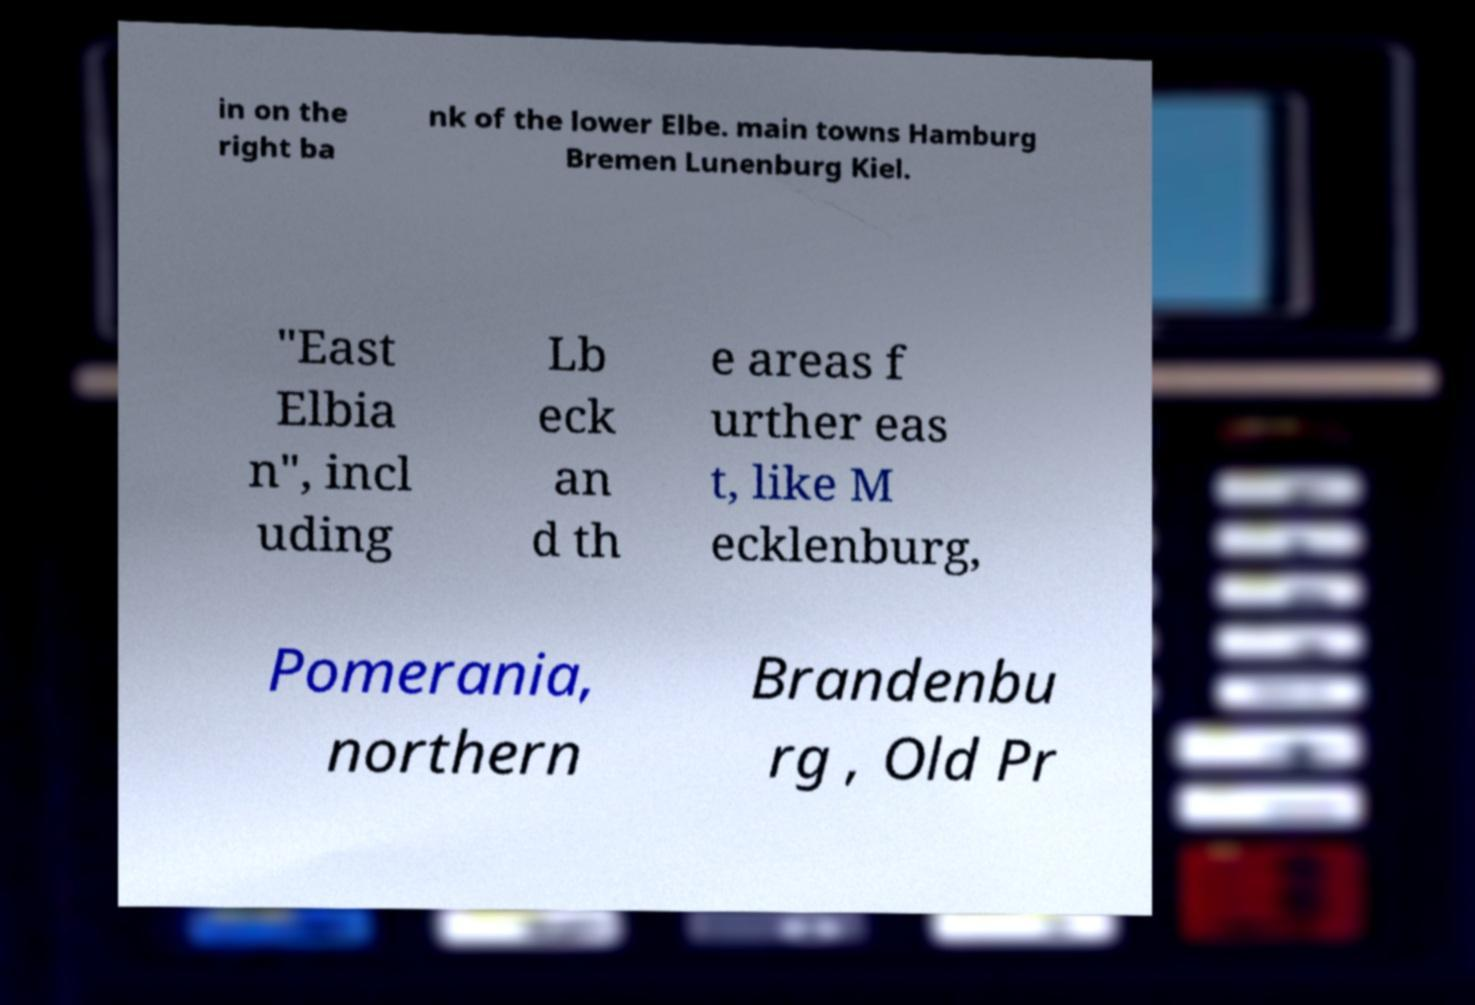Could you extract and type out the text from this image? in on the right ba nk of the lower Elbe. main towns Hamburg Bremen Lunenburg Kiel. "East Elbia n", incl uding Lb eck an d th e areas f urther eas t, like M ecklenburg, Pomerania, northern Brandenbu rg , Old Pr 